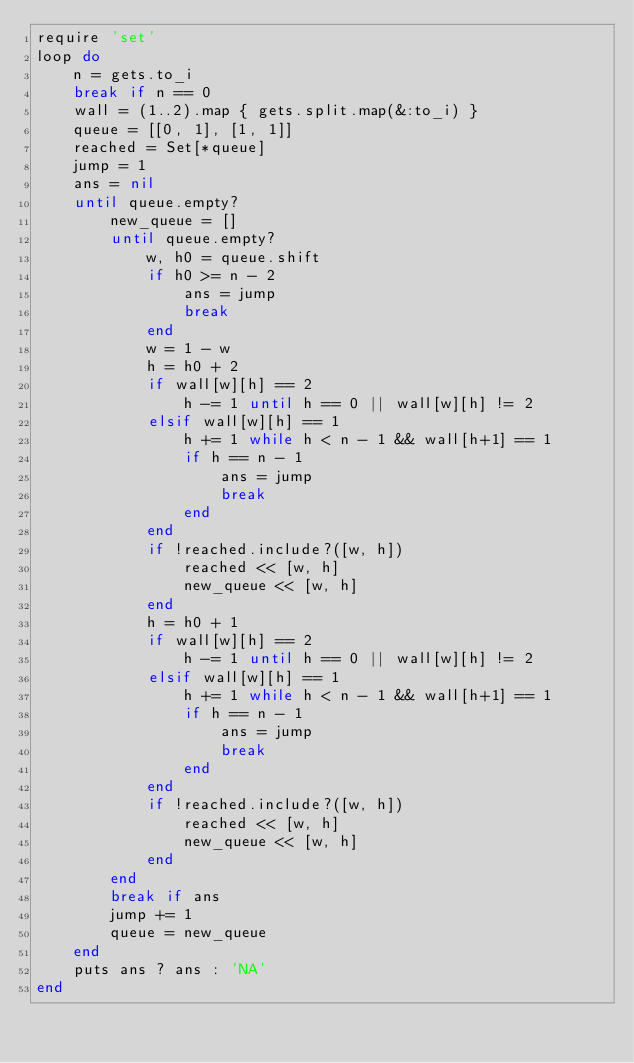Convert code to text. <code><loc_0><loc_0><loc_500><loc_500><_Ruby_>require 'set'
loop do
    n = gets.to_i
    break if n == 0
    wall = (1..2).map { gets.split.map(&:to_i) }
    queue = [[0, 1], [1, 1]]
    reached = Set[*queue]
    jump = 1
    ans = nil
    until queue.empty?
        new_queue = []
        until queue.empty?
            w, h0 = queue.shift
            if h0 >= n - 2
                ans = jump
                break
            end
            w = 1 - w
            h = h0 + 2
            if wall[w][h] == 2
                h -= 1 until h == 0 || wall[w][h] != 2
            elsif wall[w][h] == 1
                h += 1 while h < n - 1 && wall[h+1] == 1
                if h == n - 1
                    ans = jump
                    break
                end
            end
            if !reached.include?([w, h])
                reached << [w, h]
                new_queue << [w, h]
            end
            h = h0 + 1
            if wall[w][h] == 2
                h -= 1 until h == 0 || wall[w][h] != 2
            elsif wall[w][h] == 1
                h += 1 while h < n - 1 && wall[h+1] == 1
                if h == n - 1
                    ans = jump
                    break
                end
            end
            if !reached.include?([w, h])
                reached << [w, h]
                new_queue << [w, h]
            end
        end
        break if ans
        jump += 1
        queue = new_queue
    end
    puts ans ? ans : 'NA'
end

</code> 